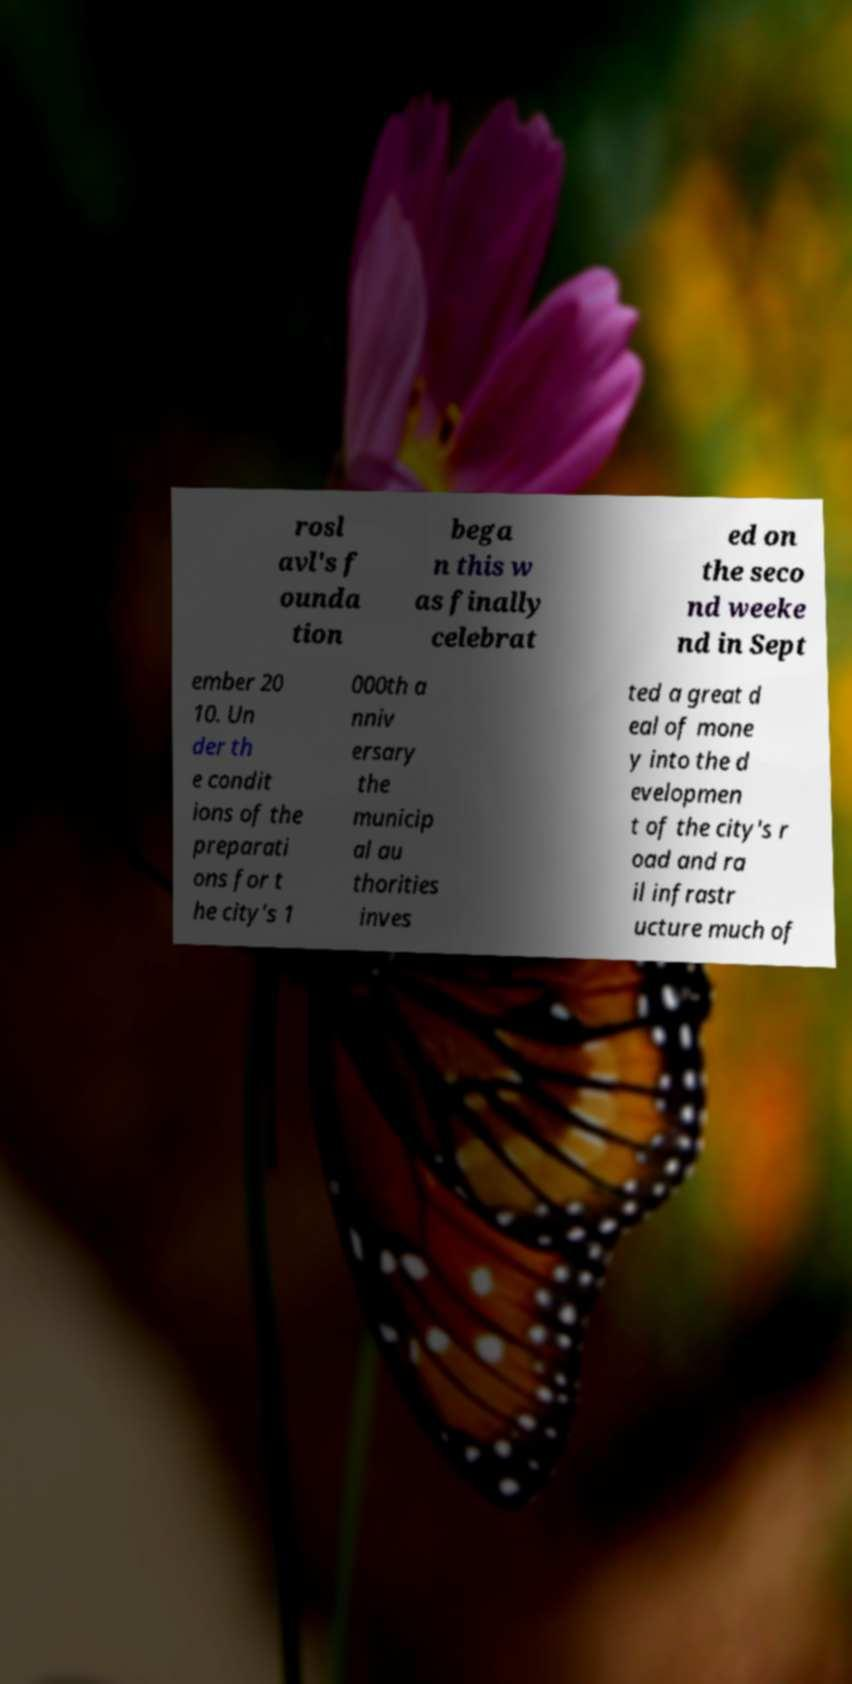Can you accurately transcribe the text from the provided image for me? rosl avl's f ounda tion bega n this w as finally celebrat ed on the seco nd weeke nd in Sept ember 20 10. Un der th e condit ions of the preparati ons for t he city's 1 000th a nniv ersary the municip al au thorities inves ted a great d eal of mone y into the d evelopmen t of the city's r oad and ra il infrastr ucture much of 